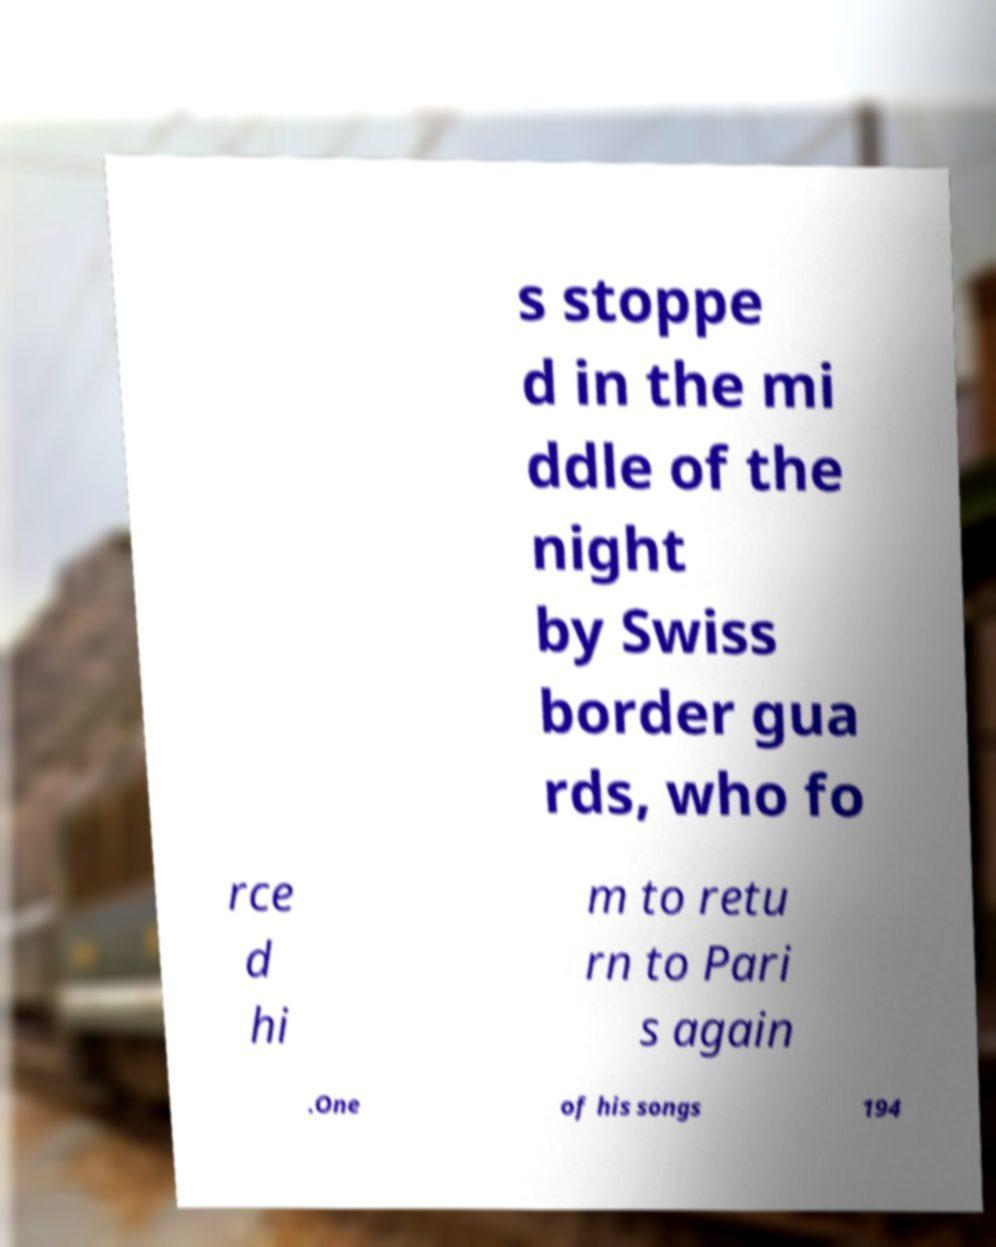Can you accurately transcribe the text from the provided image for me? s stoppe d in the mi ddle of the night by Swiss border gua rds, who fo rce d hi m to retu rn to Pari s again .One of his songs 194 